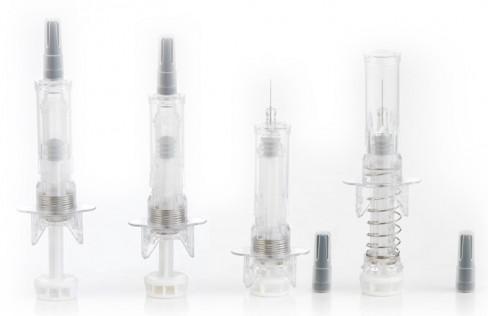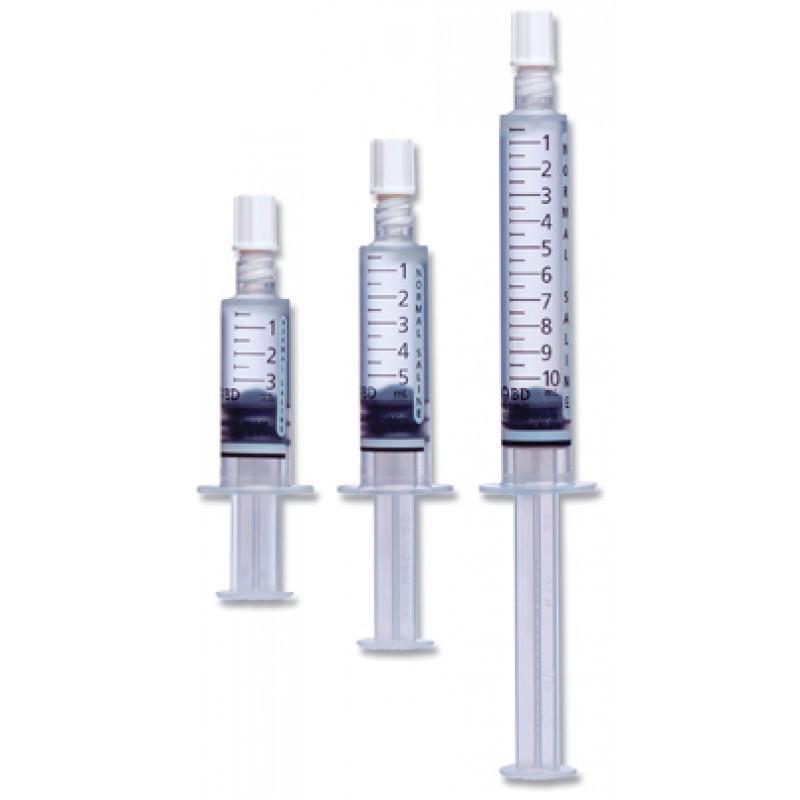The first image is the image on the left, the second image is the image on the right. Analyze the images presented: Is the assertion "There are at least 7 syringes on the images." valid? Answer yes or no. Yes. 